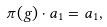<formula> <loc_0><loc_0><loc_500><loc_500>\pi ( g ) \cdot a _ { 1 } = a _ { 1 } ,</formula> 